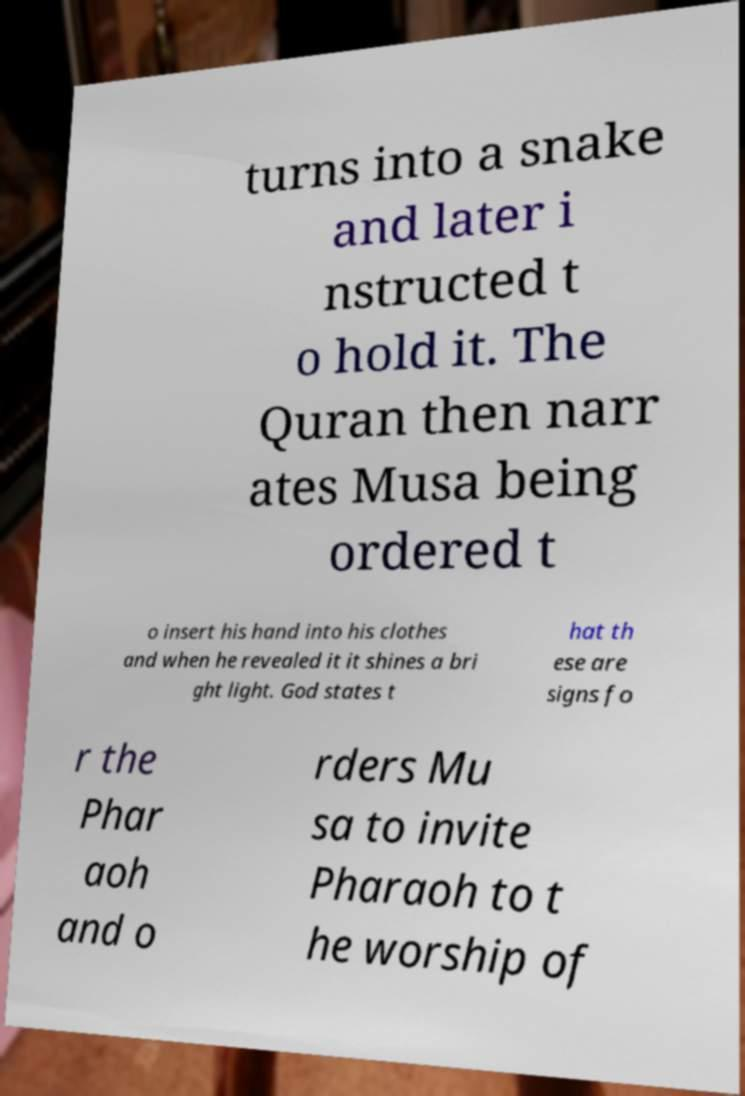Could you extract and type out the text from this image? turns into a snake and later i nstructed t o hold it. The Quran then narr ates Musa being ordered t o insert his hand into his clothes and when he revealed it it shines a bri ght light. God states t hat th ese are signs fo r the Phar aoh and o rders Mu sa to invite Pharaoh to t he worship of 